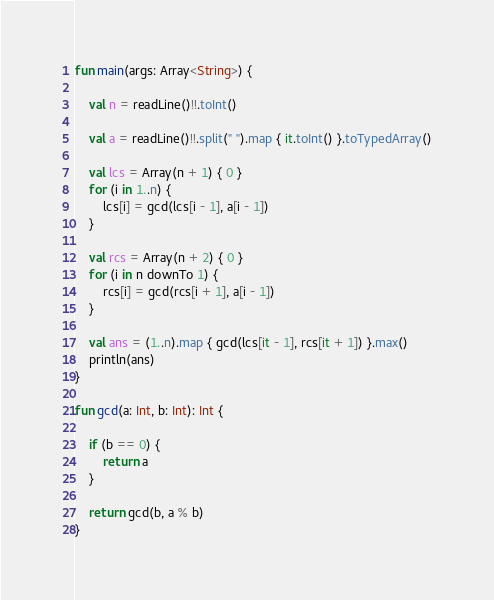<code> <loc_0><loc_0><loc_500><loc_500><_Kotlin_>fun main(args: Array<String>) {

    val n = readLine()!!.toInt()

    val a = readLine()!!.split(" ").map { it.toInt() }.toTypedArray()

    val lcs = Array(n + 1) { 0 }
    for (i in 1..n) {
        lcs[i] = gcd(lcs[i - 1], a[i - 1])
    }

    val rcs = Array(n + 2) { 0 }
    for (i in n downTo 1) {
        rcs[i] = gcd(rcs[i + 1], a[i - 1])
    }

    val ans = (1..n).map { gcd(lcs[it - 1], rcs[it + 1]) }.max()
    println(ans)
}

fun gcd(a: Int, b: Int): Int {

    if (b == 0) {
        return a
    }

    return gcd(b, a % b)
}
</code> 